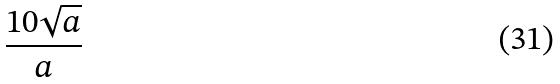<formula> <loc_0><loc_0><loc_500><loc_500>\frac { 1 0 \sqrt { a } } { a }</formula> 